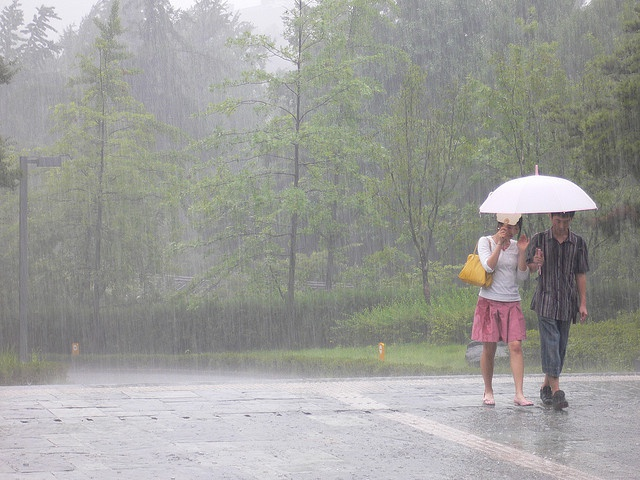Describe the objects in this image and their specific colors. I can see people in lavender, gray, and black tones, people in lavender, darkgray, gray, and salmon tones, umbrella in lavender, darkgray, gray, and pink tones, and handbag in lavender, tan, and gray tones in this image. 